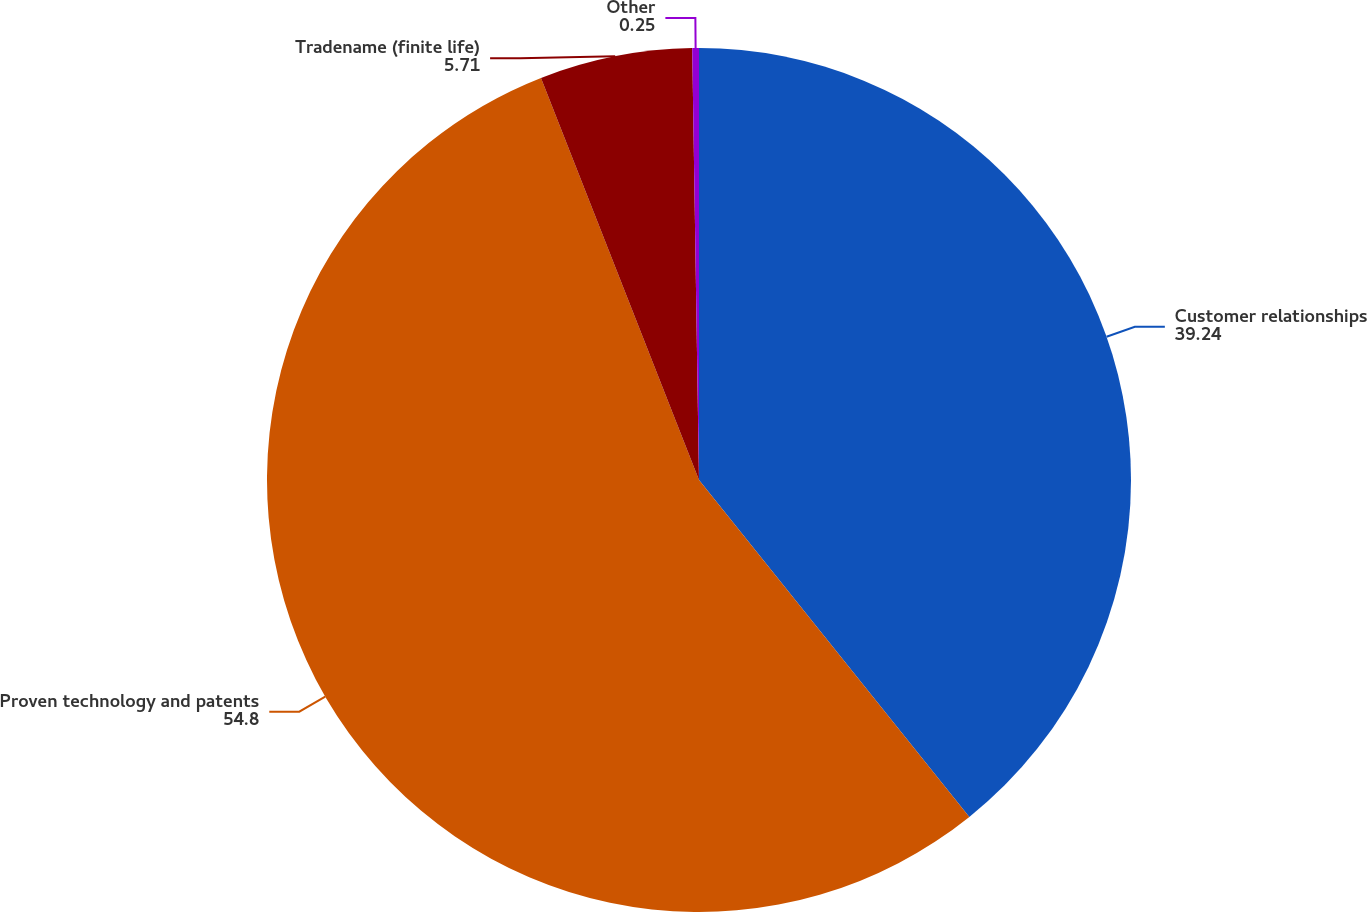Convert chart to OTSL. <chart><loc_0><loc_0><loc_500><loc_500><pie_chart><fcel>Customer relationships<fcel>Proven technology and patents<fcel>Tradename (finite life)<fcel>Other<nl><fcel>39.24%<fcel>54.8%<fcel>5.71%<fcel>0.25%<nl></chart> 